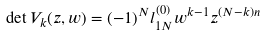<formula> <loc_0><loc_0><loc_500><loc_500>\det V _ { k } ( z , w ) = ( - 1 ) ^ { N } l _ { 1 N } ^ { ( 0 ) } w ^ { k - 1 } z ^ { ( N - k ) n }</formula> 